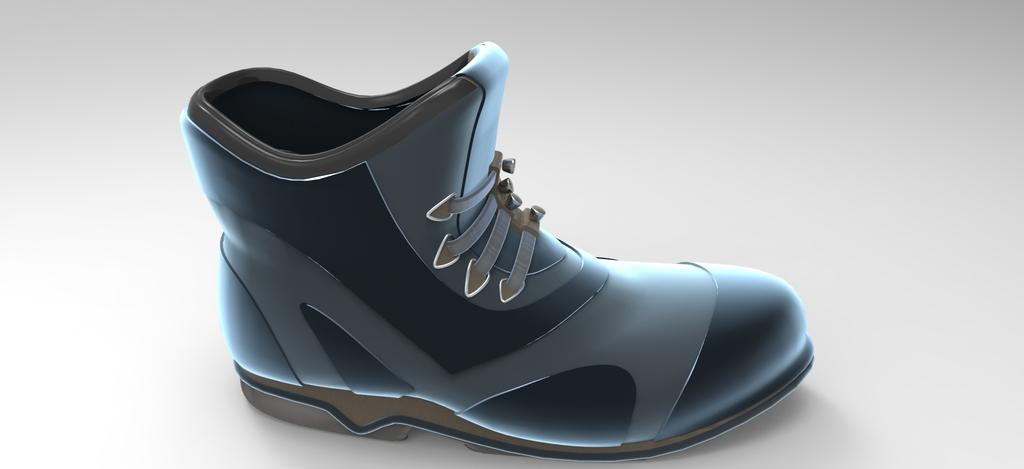What is the main subject of the image? The main subject of the image is an animated picture of a shoe. Can you describe the shoe in the image? Unfortunately, the facts provided do not give any specific details about the shoe's appearance or animation. How many people are smiling in the image? There are no people present in the image, only an animated picture of a shoe. What type of hole can be seen in the image? There is no hole present in the image; it contains an animated picture of a shoe. 